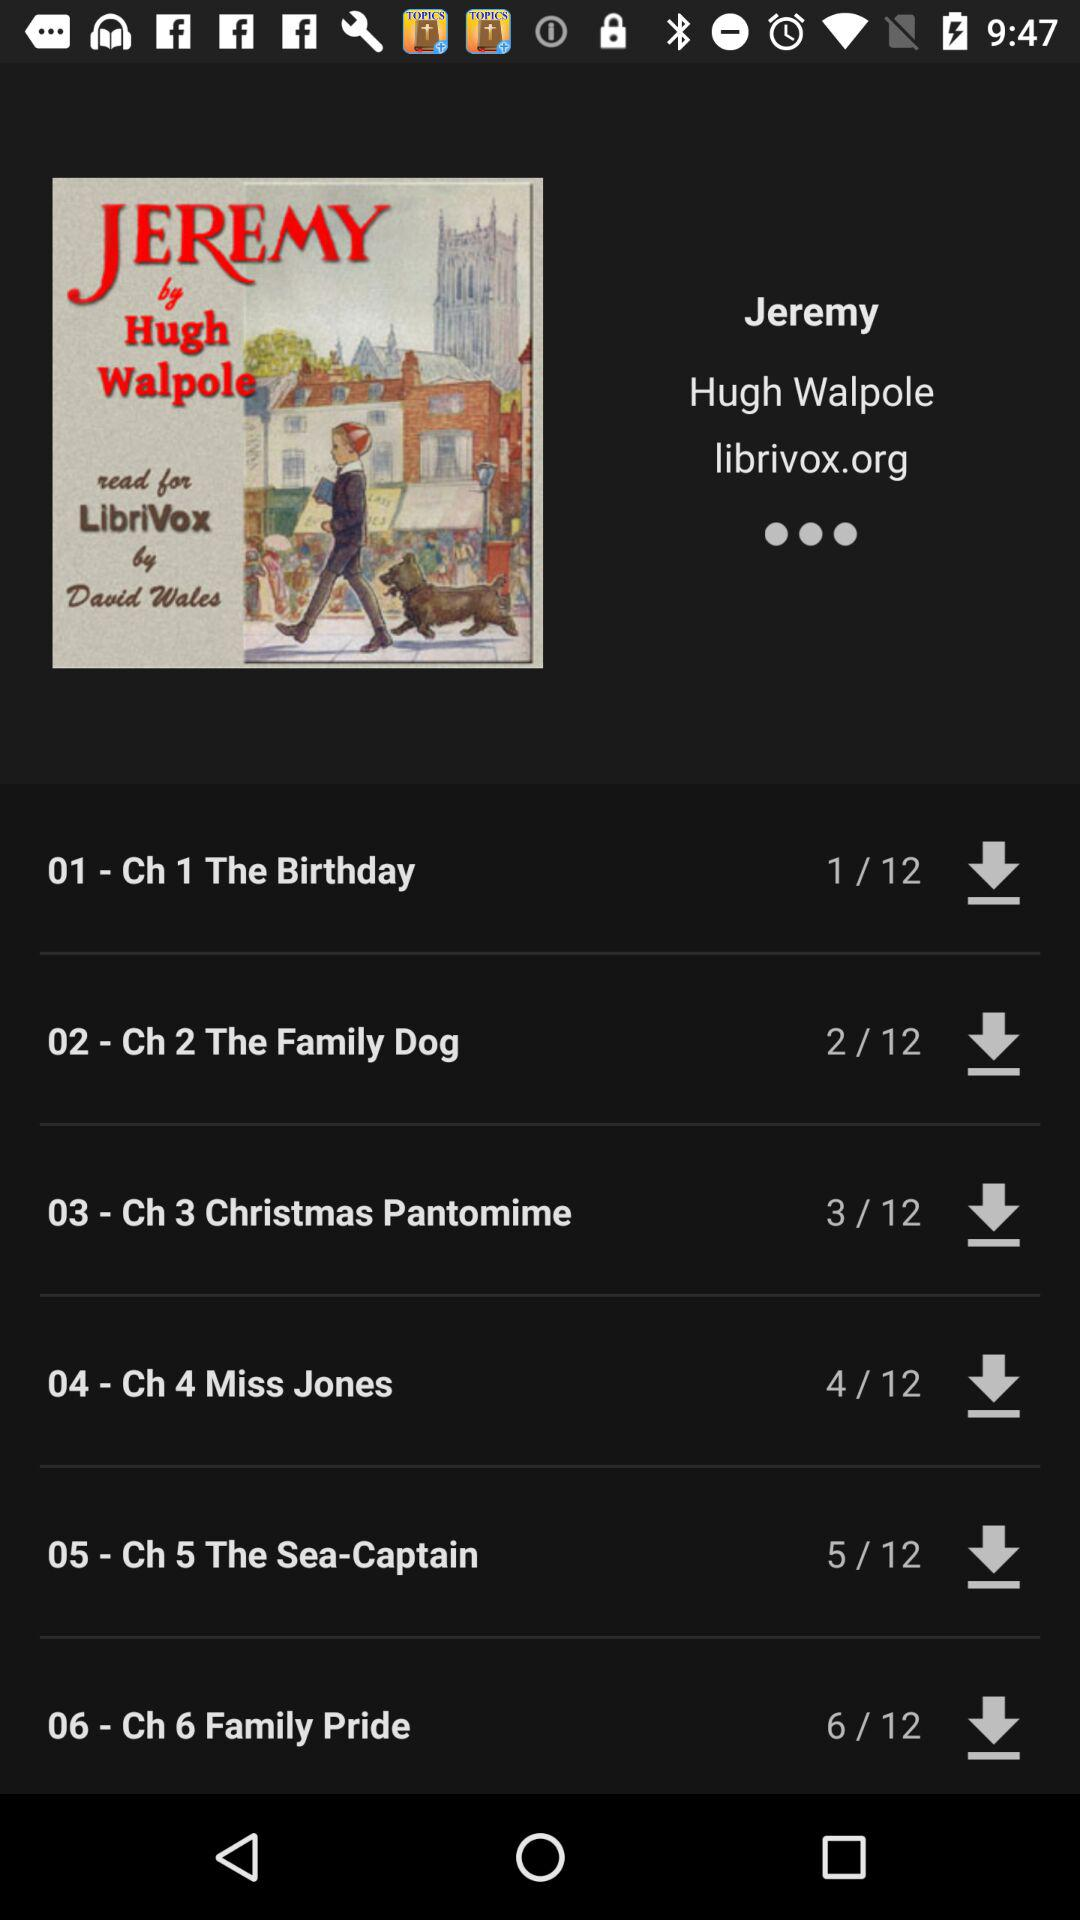How many chapters are there in this book?
Answer the question using a single word or phrase. 6 